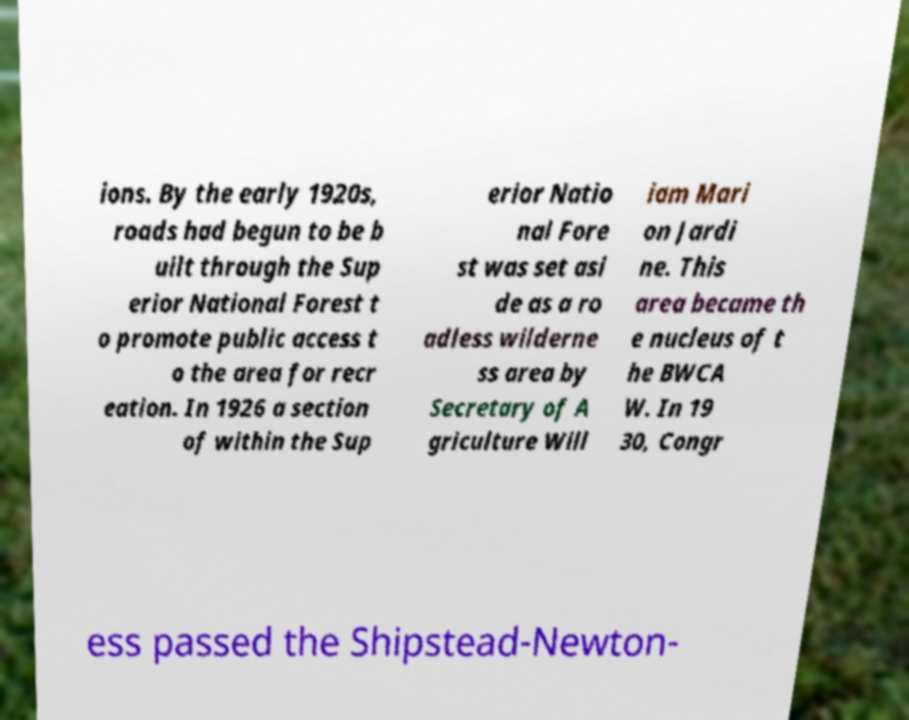Can you read and provide the text displayed in the image?This photo seems to have some interesting text. Can you extract and type it out for me? ions. By the early 1920s, roads had begun to be b uilt through the Sup erior National Forest t o promote public access t o the area for recr eation. In 1926 a section of within the Sup erior Natio nal Fore st was set asi de as a ro adless wilderne ss area by Secretary of A griculture Will iam Mari on Jardi ne. This area became th e nucleus of t he BWCA W. In 19 30, Congr ess passed the Shipstead-Newton- 